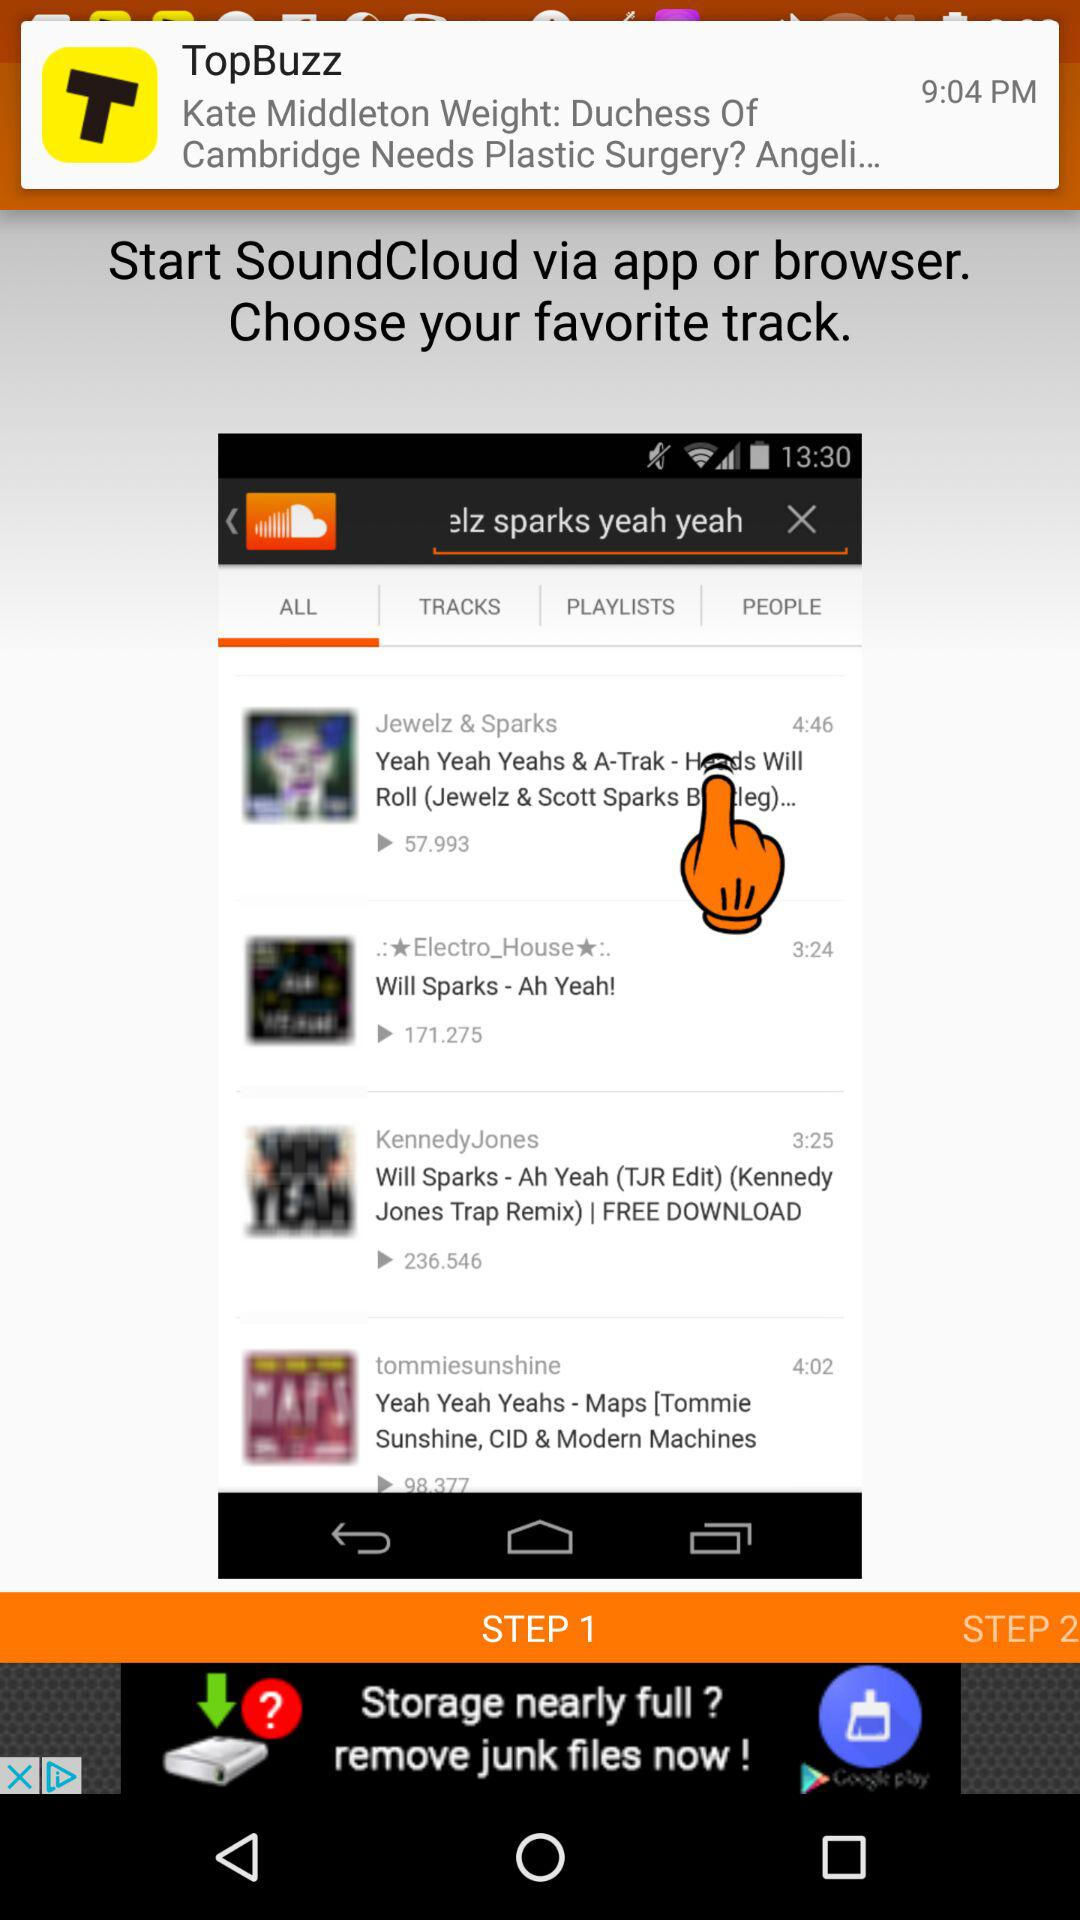How many steps are there in the process?
Answer the question using a single word or phrase. 2 